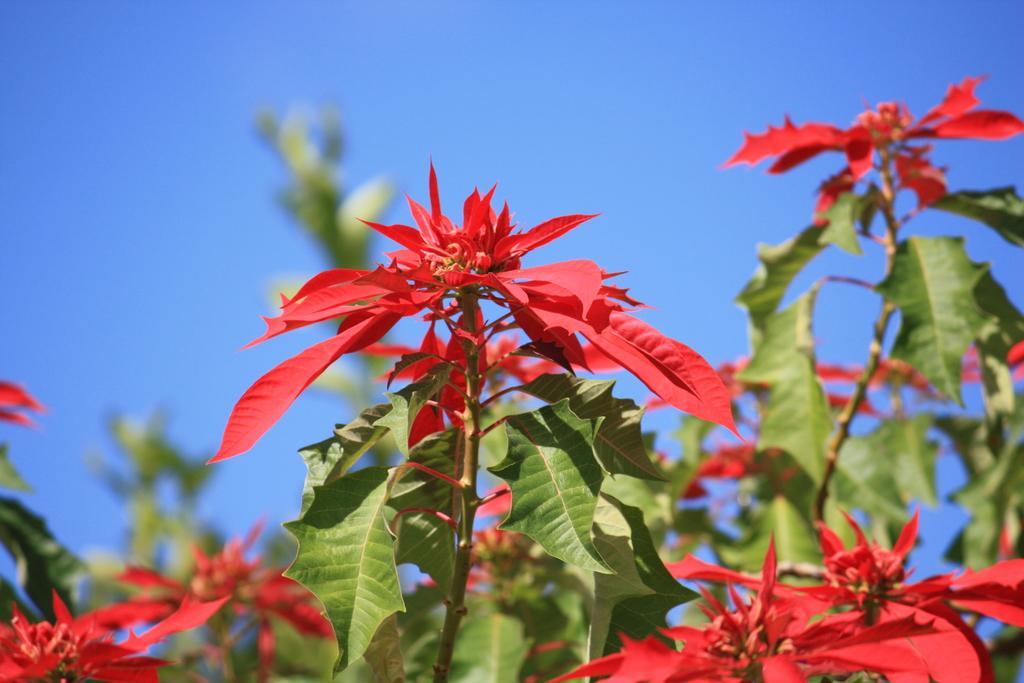Describe this image in one or two sentences. This image is taken outdoors. At the top of the image there is the sky. At the bottom of the image there are a few plants with green leaves and red flowers. 